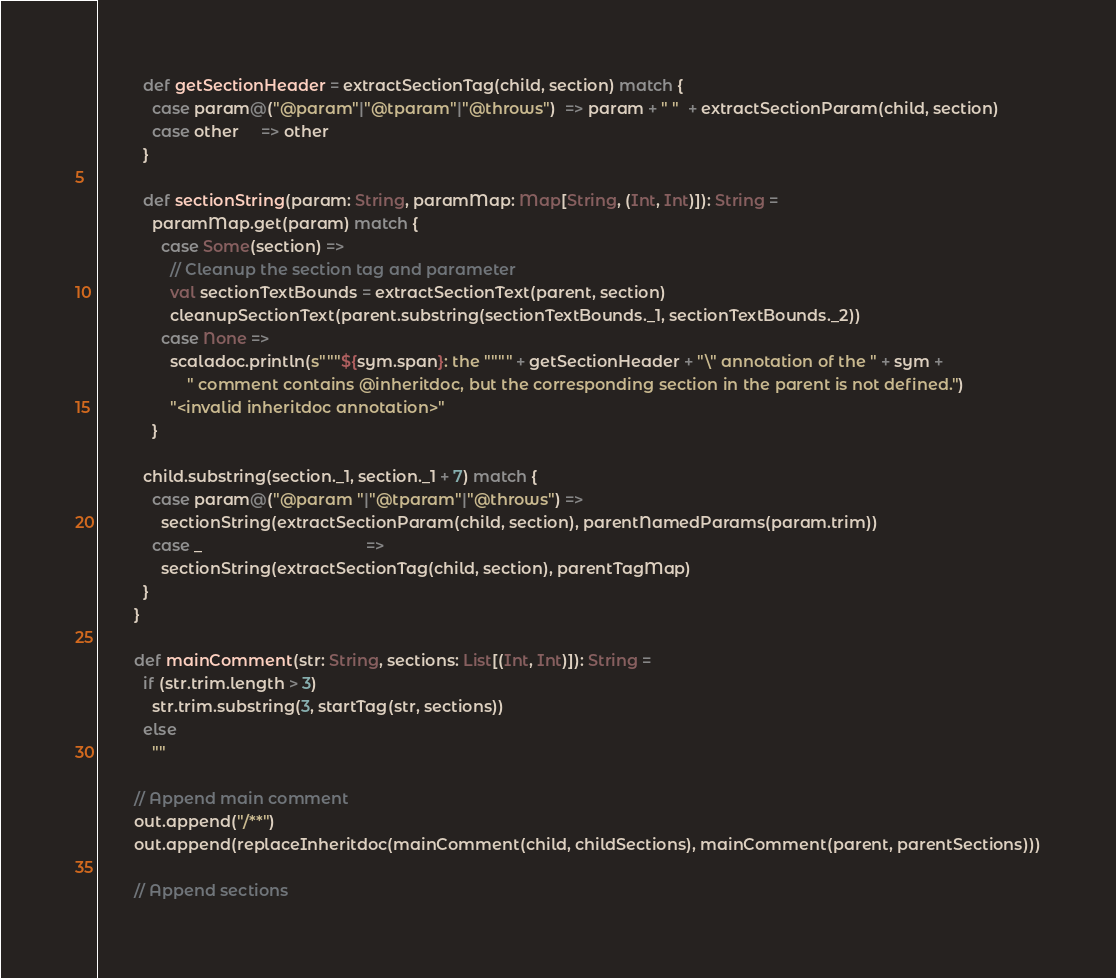Convert code to text. <code><loc_0><loc_0><loc_500><loc_500><_Scala_>
          def getSectionHeader = extractSectionTag(child, section) match {
            case param@("@param"|"@tparam"|"@throws")  => param + " "  + extractSectionParam(child, section)
            case other     => other
          }

          def sectionString(param: String, paramMap: Map[String, (Int, Int)]): String =
            paramMap.get(param) match {
              case Some(section) =>
                // Cleanup the section tag and parameter
                val sectionTextBounds = extractSectionText(parent, section)
                cleanupSectionText(parent.substring(sectionTextBounds._1, sectionTextBounds._2))
              case None =>
                scaladoc.println(s"""${sym.span}: the """" + getSectionHeader + "\" annotation of the " + sym +
                    " comment contains @inheritdoc, but the corresponding section in the parent is not defined.")
                "<invalid inheritdoc annotation>"
            }

          child.substring(section._1, section._1 + 7) match {
            case param@("@param "|"@tparam"|"@throws") =>
              sectionString(extractSectionParam(child, section), parentNamedParams(param.trim))
            case _                                     =>
              sectionString(extractSectionTag(child, section), parentTagMap)
          }
        }

        def mainComment(str: String, sections: List[(Int, Int)]): String =
          if (str.trim.length > 3)
            str.trim.substring(3, startTag(str, sections))
          else
            ""

        // Append main comment
        out.append("/**")
        out.append(replaceInheritdoc(mainComment(child, childSections), mainComment(parent, parentSections)))

        // Append sections</code> 